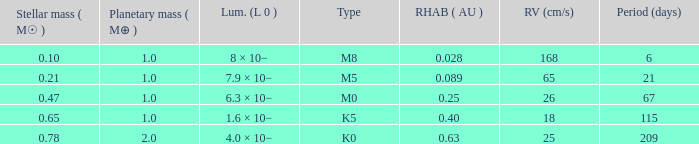What is the total stellar mass of the type m0? 0.47. Can you parse all the data within this table? {'header': ['Stellar mass ( M☉ )', 'Planetary mass ( M⊕ )', 'Lum. (L 0 )', 'Type', 'RHAB ( AU )', 'RV (cm/s)', 'Period (days)'], 'rows': [['0.10', '1.0', '8 × 10−', 'M8', '0.028', '168', '6'], ['0.21', '1.0', '7.9 × 10−', 'M5', '0.089', '65', '21'], ['0.47', '1.0', '6.3 × 10−', 'M0', '0.25', '26', '67'], ['0.65', '1.0', '1.6 × 10−', 'K5', '0.40', '18', '115'], ['0.78', '2.0', '4.0 × 10−', 'K0', '0.63', '25', '209']]} 